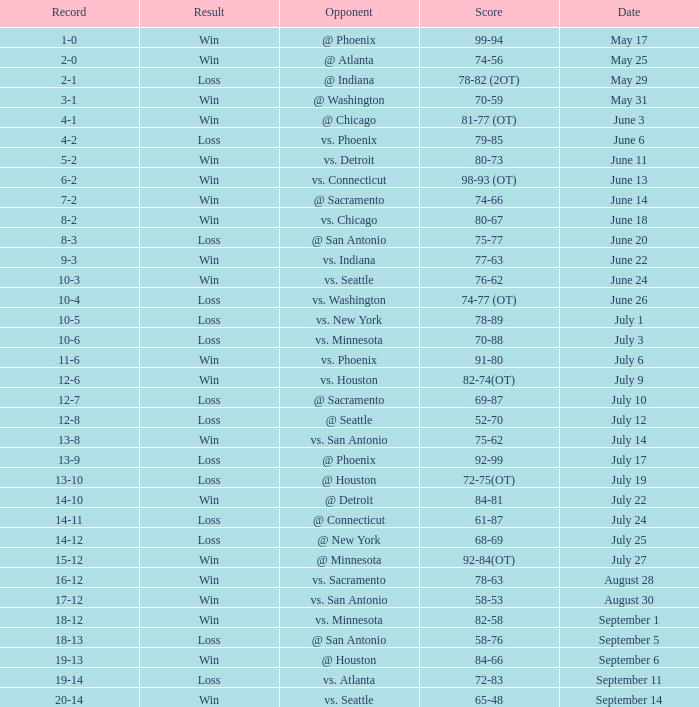What is the Record of the game with a Score of 65-48? 20-14. 